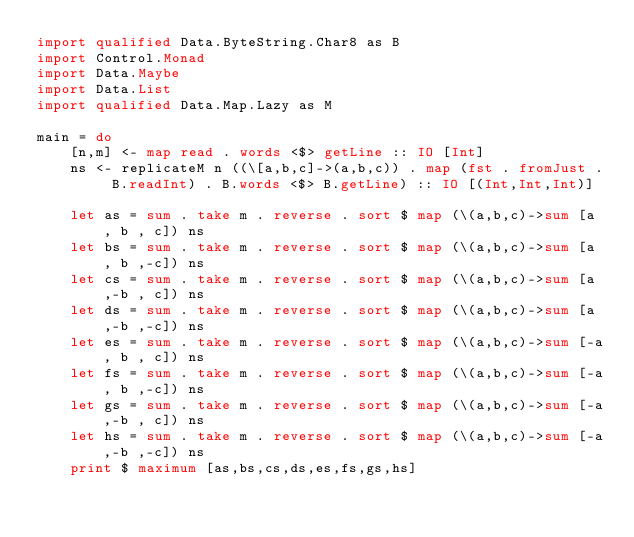Convert code to text. <code><loc_0><loc_0><loc_500><loc_500><_Haskell_>import qualified Data.ByteString.Char8 as B
import Control.Monad
import Data.Maybe
import Data.List
import qualified Data.Map.Lazy as M

main = do
    [n,m] <- map read . words <$> getLine :: IO [Int]
    ns <- replicateM n ((\[a,b,c]->(a,b,c)) . map (fst . fromJust . B.readInt) . B.words <$> B.getLine) :: IO [(Int,Int,Int)]

    let as = sum . take m . reverse . sort $ map (\(a,b,c)->sum [a , b , c]) ns
    let bs = sum . take m . reverse . sort $ map (\(a,b,c)->sum [a , b ,-c]) ns
    let cs = sum . take m . reverse . sort $ map (\(a,b,c)->sum [a ,-b , c]) ns
    let ds = sum . take m . reverse . sort $ map (\(a,b,c)->sum [a ,-b ,-c]) ns
    let es = sum . take m . reverse . sort $ map (\(a,b,c)->sum [-a, b , c]) ns
    let fs = sum . take m . reverse . sort $ map (\(a,b,c)->sum [-a, b ,-c]) ns
    let gs = sum . take m . reverse . sort $ map (\(a,b,c)->sum [-a,-b , c]) ns
    let hs = sum . take m . reverse . sort $ map (\(a,b,c)->sum [-a,-b ,-c]) ns
    print $ maximum [as,bs,cs,ds,es,fs,gs,hs]
</code> 